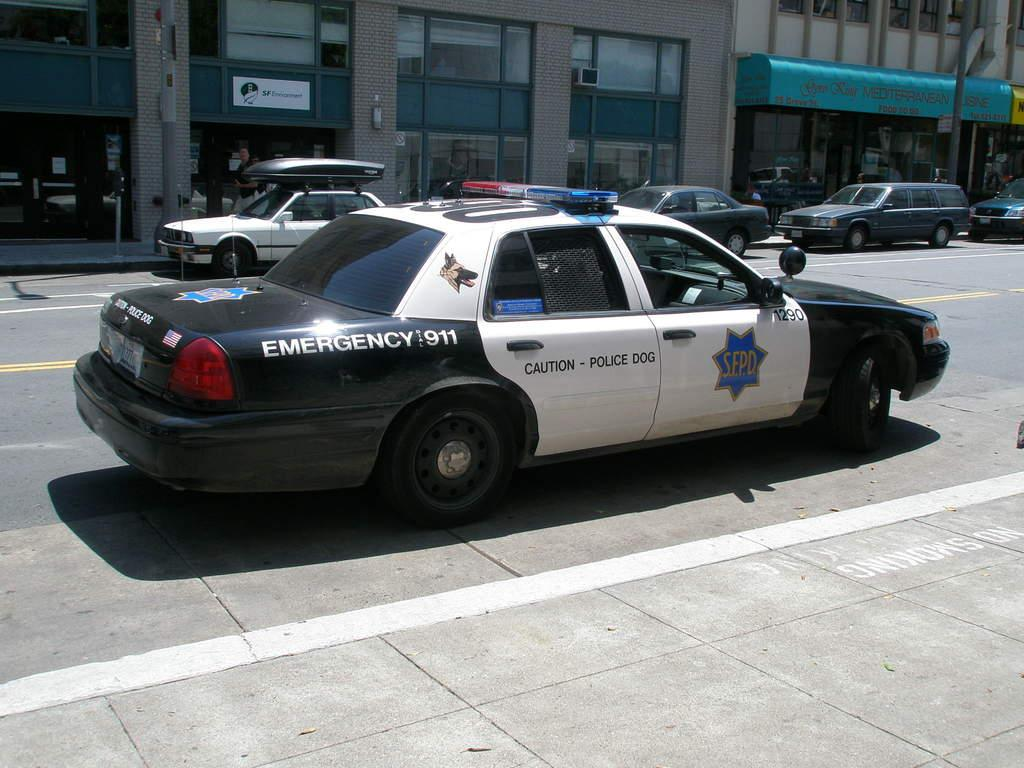What is the main subject of the image? The main subject of the image is vehicles on the road. Where are the vehicles located in the image? The vehicles are in the center of the image. What can be seen in the background of the image? There are buildings and poles in the background of the image. What type of food is being served in the story depicted in the image? There is no story or food present in the image; it features vehicles on the road with buildings and poles in the background. 